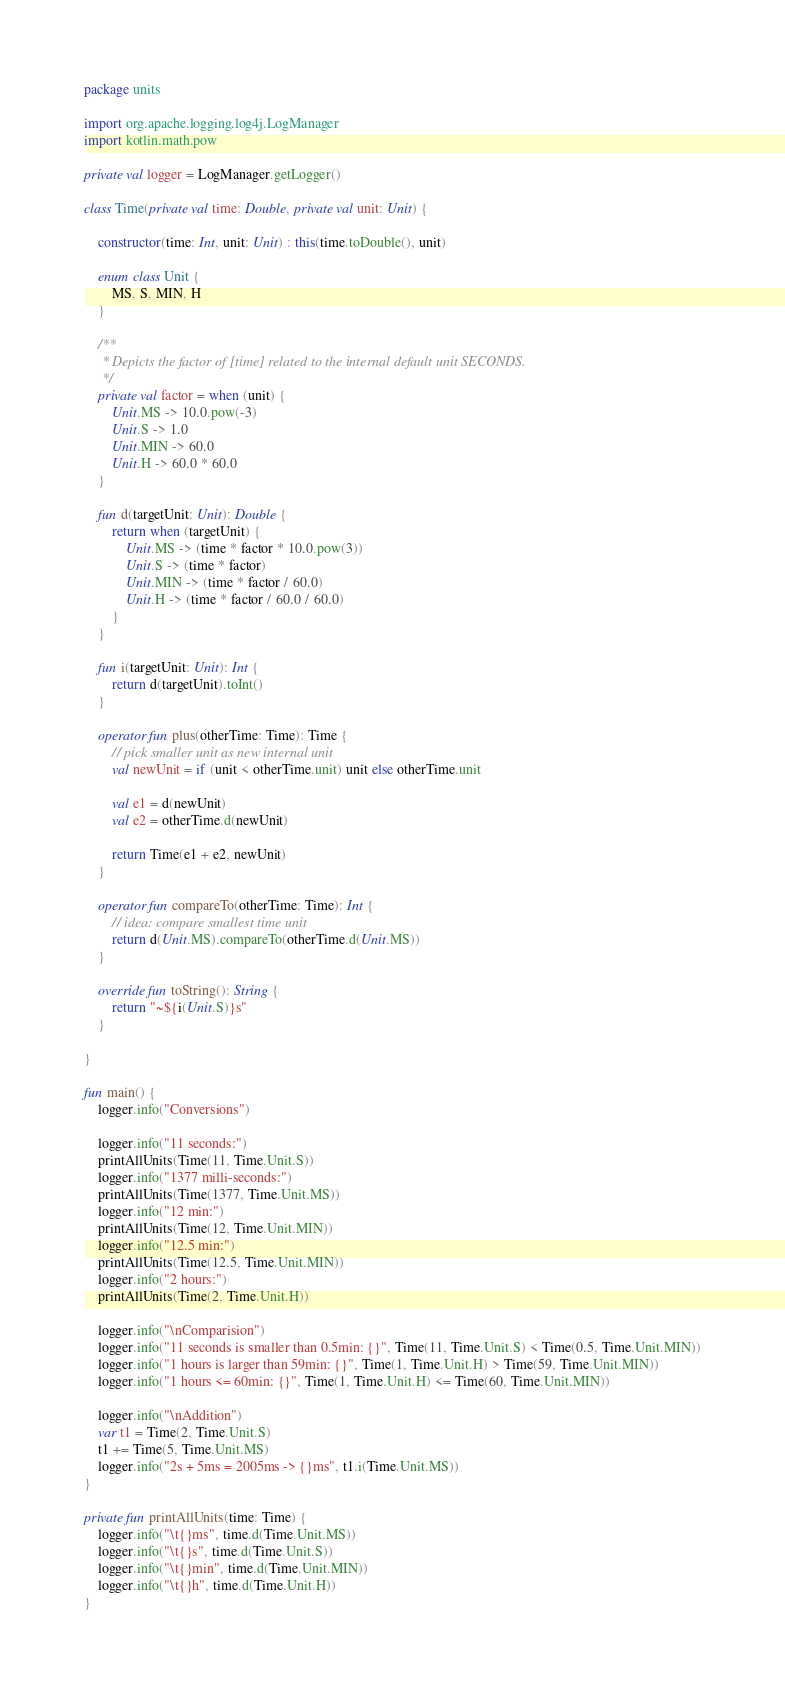Convert code to text. <code><loc_0><loc_0><loc_500><loc_500><_Kotlin_>package units

import org.apache.logging.log4j.LogManager
import kotlin.math.pow

private val logger = LogManager.getLogger()

class Time(private val time: Double, private val unit: Unit) {

    constructor(time: Int, unit: Unit) : this(time.toDouble(), unit)

    enum class Unit {
        MS, S, MIN, H
    }

    /**
     * Depicts the factor of [time] related to the internal default unit SECONDS.
     */
    private val factor = when (unit) {
        Unit.MS -> 10.0.pow(-3)
        Unit.S -> 1.0
        Unit.MIN -> 60.0
        Unit.H -> 60.0 * 60.0
    }

    fun d(targetUnit: Unit): Double {
        return when (targetUnit) {
            Unit.MS -> (time * factor * 10.0.pow(3))
            Unit.S -> (time * factor)
            Unit.MIN -> (time * factor / 60.0)
            Unit.H -> (time * factor / 60.0 / 60.0)
        }
    }

    fun i(targetUnit: Unit): Int {
        return d(targetUnit).toInt()
    }

    operator fun plus(otherTime: Time): Time {
        // pick smaller unit as new internal unit
        val newUnit = if (unit < otherTime.unit) unit else otherTime.unit

        val e1 = d(newUnit)
        val e2 = otherTime.d(newUnit)

        return Time(e1 + e2, newUnit)
    }

    operator fun compareTo(otherTime: Time): Int {
        // idea: compare smallest time unit
        return d(Unit.MS).compareTo(otherTime.d(Unit.MS))
    }

    override fun toString(): String {
        return "~${i(Unit.S)}s"
    }

}

fun main() {
    logger.info("Conversions")

    logger.info("11 seconds:")
    printAllUnits(Time(11, Time.Unit.S))
    logger.info("1377 milli-seconds:")
    printAllUnits(Time(1377, Time.Unit.MS))
    logger.info("12 min:")
    printAllUnits(Time(12, Time.Unit.MIN))
    logger.info("12.5 min:")
    printAllUnits(Time(12.5, Time.Unit.MIN))
    logger.info("2 hours:")
    printAllUnits(Time(2, Time.Unit.H))

    logger.info("\nComparision")
    logger.info("11 seconds is smaller than 0.5min: {}", Time(11, Time.Unit.S) < Time(0.5, Time.Unit.MIN))
    logger.info("1 hours is larger than 59min: {}", Time(1, Time.Unit.H) > Time(59, Time.Unit.MIN))
    logger.info("1 hours <= 60min: {}", Time(1, Time.Unit.H) <= Time(60, Time.Unit.MIN))

    logger.info("\nAddition")
    var t1 = Time(2, Time.Unit.S)
    t1 += Time(5, Time.Unit.MS)
    logger.info("2s + 5ms = 2005ms -> {}ms", t1.i(Time.Unit.MS))
}

private fun printAllUnits(time: Time) {
    logger.info("\t{}ms", time.d(Time.Unit.MS))
    logger.info("\t{}s", time.d(Time.Unit.S))
    logger.info("\t{}min", time.d(Time.Unit.MIN))
    logger.info("\t{}h", time.d(Time.Unit.H))
}</code> 